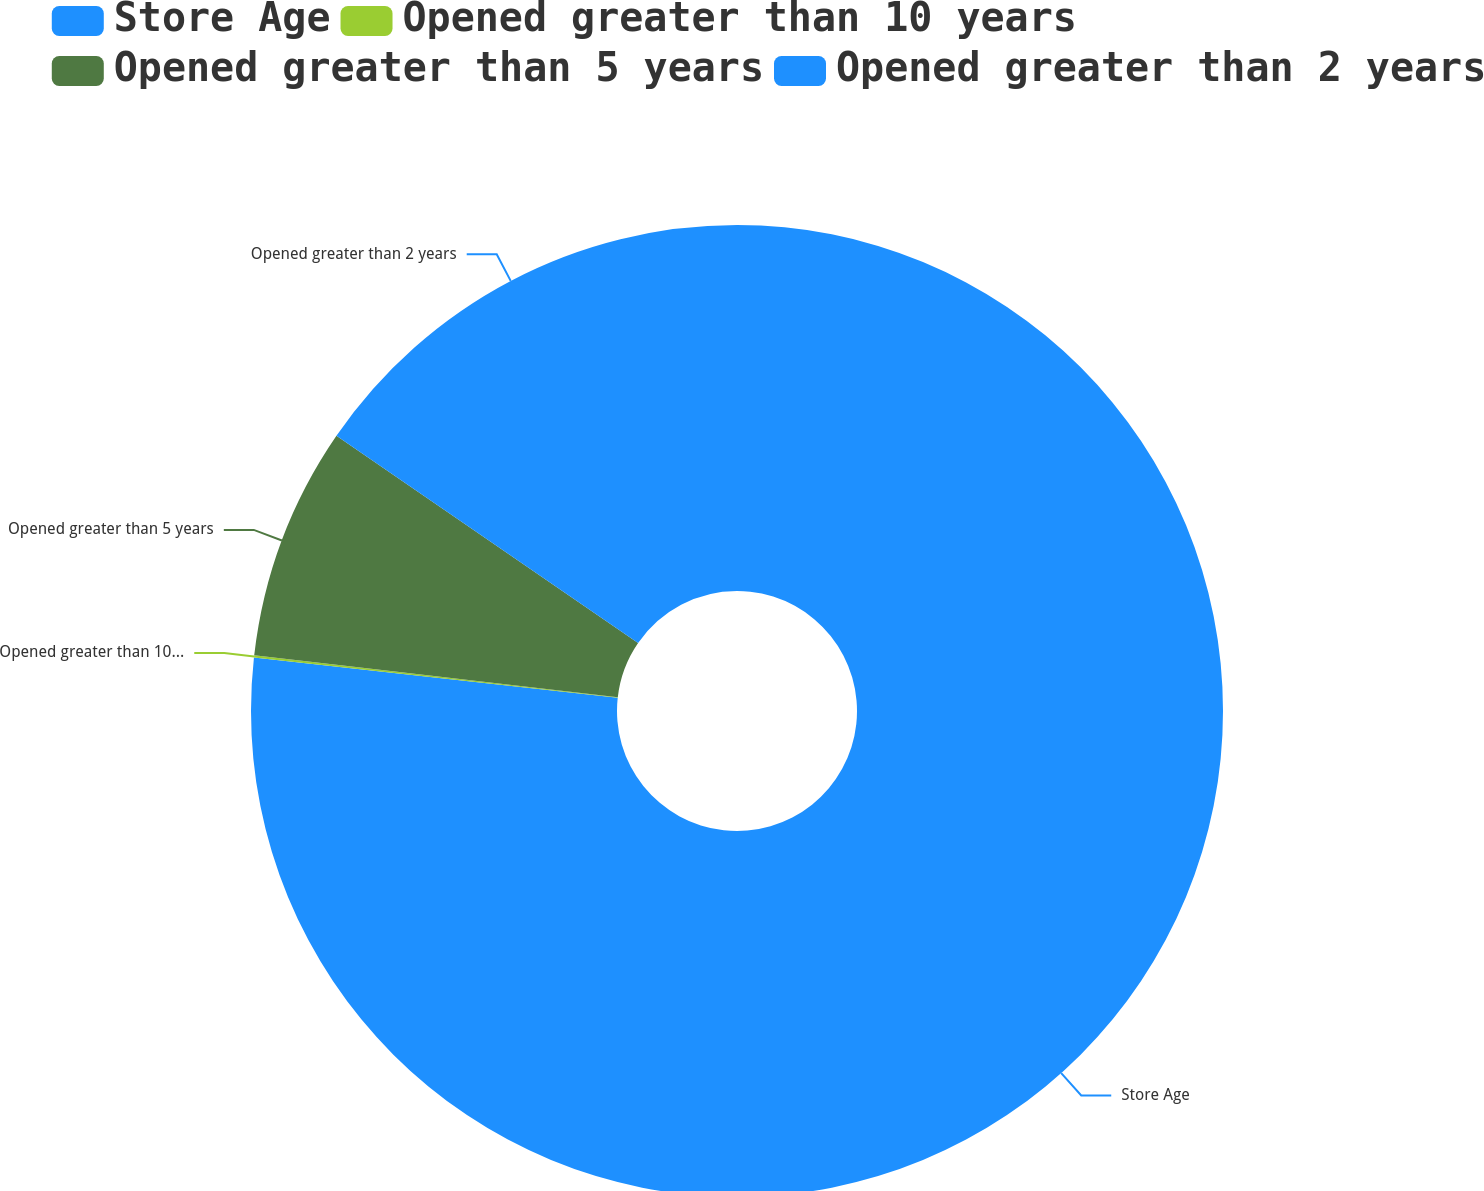Convert chart. <chart><loc_0><loc_0><loc_500><loc_500><pie_chart><fcel>Store Age<fcel>Opened greater than 10 years<fcel>Opened greater than 5 years<fcel>Opened greater than 2 years<nl><fcel>76.76%<fcel>0.08%<fcel>7.75%<fcel>15.42%<nl></chart> 